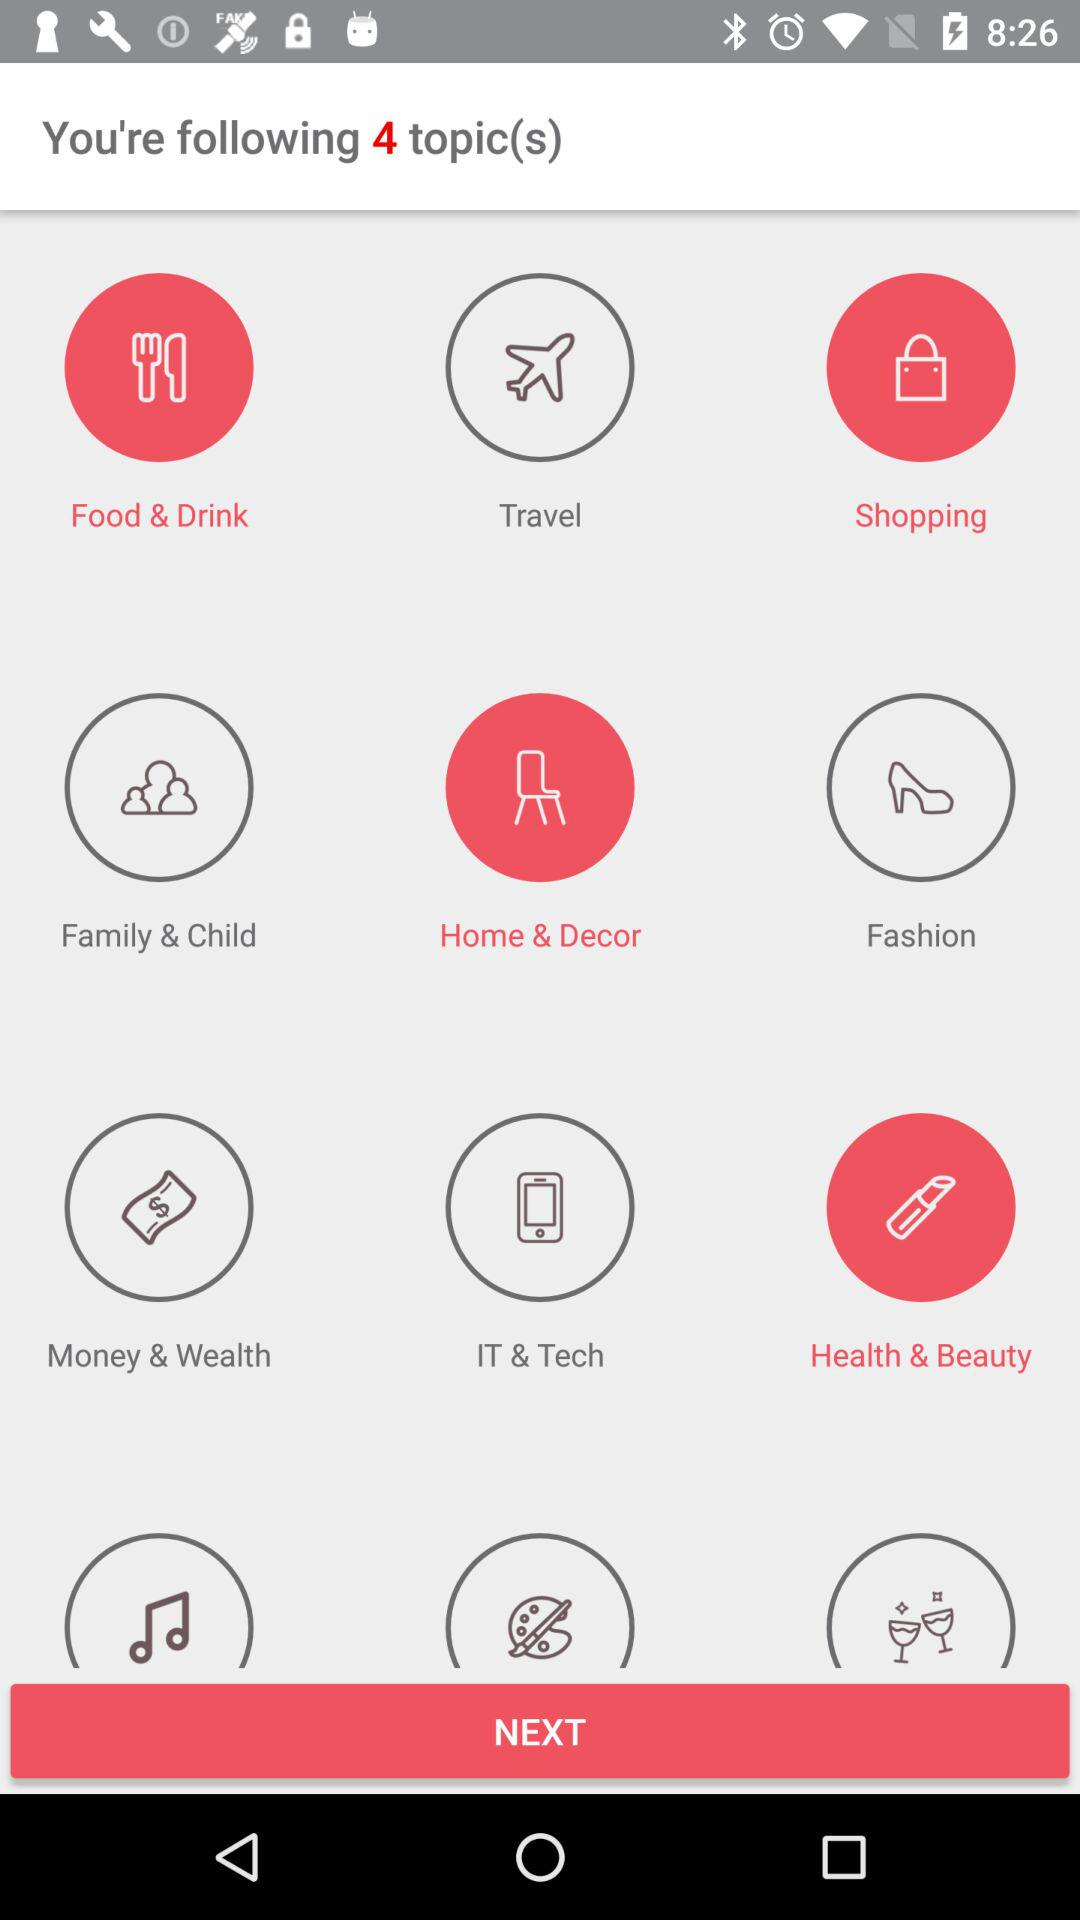What are the selected topics? The selected topics are "Food & Drink", "Shopping", "Home & Decor" and "Health & Beauty". 